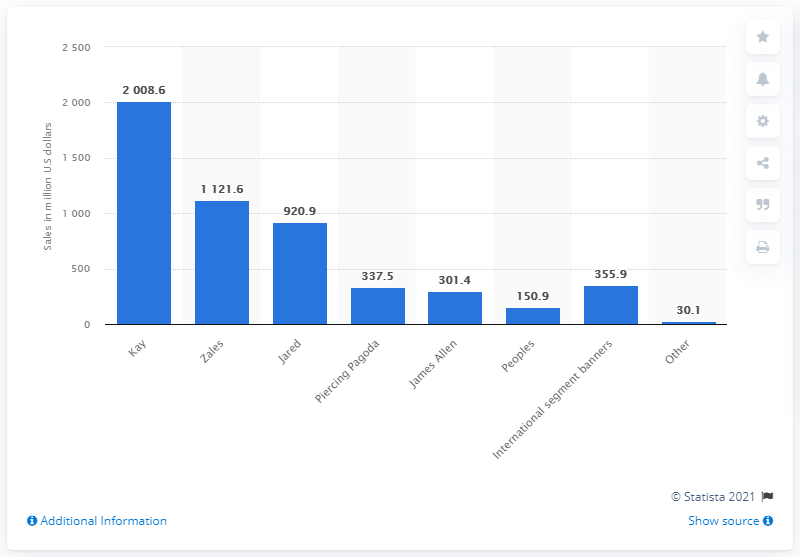Identify some key points in this picture. Signet Jewelers owned the brand Kay in 2021. 